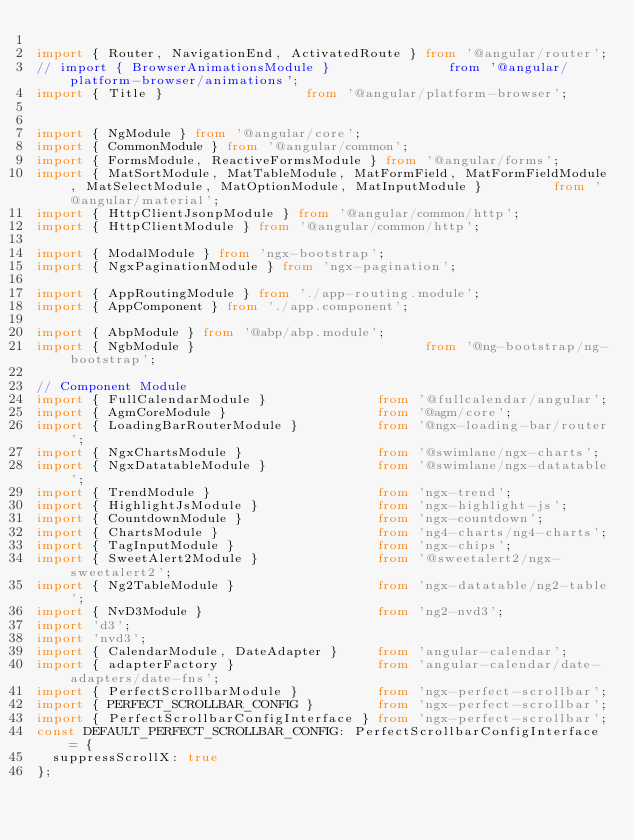<code> <loc_0><loc_0><loc_500><loc_500><_TypeScript_>
import { Router, NavigationEnd, ActivatedRoute } from '@angular/router';
// import { BrowserAnimationsModule }               from '@angular/platform-browser/animations';
import { Title }                  from '@angular/platform-browser';


import { NgModule } from '@angular/core';
import { CommonModule } from '@angular/common';
import { FormsModule, ReactiveFormsModule } from '@angular/forms';
import { MatSortModule, MatTableModule, MatFormField, MatFormFieldModule, MatSelectModule, MatOptionModule, MatInputModule }         from '@angular/material';
import { HttpClientJsonpModule } from '@angular/common/http';
import { HttpClientModule } from '@angular/common/http';

import { ModalModule } from 'ngx-bootstrap';
import { NgxPaginationModule } from 'ngx-pagination';

import { AppRoutingModule } from './app-routing.module';
import { AppComponent } from './app.component';

import { AbpModule } from '@abp/abp.module';
import { NgbModule }                             from '@ng-bootstrap/ng-bootstrap';

// Component Module
import { FullCalendarModule }              from '@fullcalendar/angular';
import { AgmCoreModule }                   from '@agm/core';
import { LoadingBarRouterModule }          from '@ngx-loading-bar/router';
import { NgxChartsModule }                 from '@swimlane/ngx-charts';
import { NgxDatatableModule }              from '@swimlane/ngx-datatable';
import { TrendModule }                     from 'ngx-trend';
import { HighlightJsModule }               from 'ngx-highlight-js';
import { CountdownModule }                 from 'ngx-countdown';
import { ChartsModule }                    from 'ng4-charts/ng4-charts';
import { TagInputModule }                  from 'ngx-chips';
import { SweetAlert2Module }               from '@sweetalert2/ngx-sweetalert2';
import { Ng2TableModule }                  from 'ngx-datatable/ng2-table';
import { NvD3Module }                      from 'ng2-nvd3';
import 'd3';
import 'nvd3';
import { CalendarModule, DateAdapter }     from 'angular-calendar';
import { adapterFactory }                  from 'angular-calendar/date-adapters/date-fns';
import { PerfectScrollbarModule }          from 'ngx-perfect-scrollbar';
import { PERFECT_SCROLLBAR_CONFIG }        from 'ngx-perfect-scrollbar';
import { PerfectScrollbarConfigInterface } from 'ngx-perfect-scrollbar';
const DEFAULT_PERFECT_SCROLLBAR_CONFIG: PerfectScrollbarConfigInterface = {
  suppressScrollX: true
};
</code> 